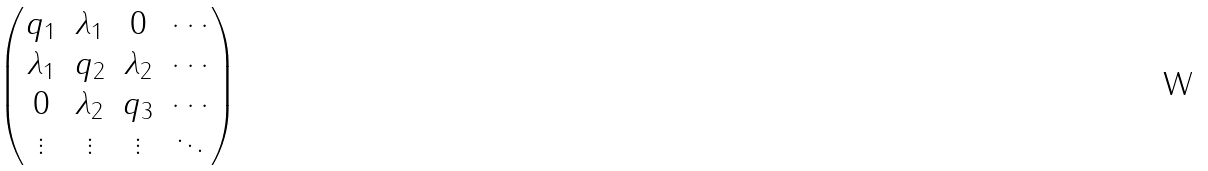Convert formula to latex. <formula><loc_0><loc_0><loc_500><loc_500>\begin{pmatrix} q _ { 1 } & \lambda _ { 1 } & 0 & \cdots \\ \lambda _ { 1 } & q _ { 2 } & \lambda _ { 2 } & \cdots \\ 0 & \lambda _ { 2 } & q _ { 3 } & \cdots \\ \vdots & \vdots & \vdots & \ddots \end{pmatrix}</formula> 